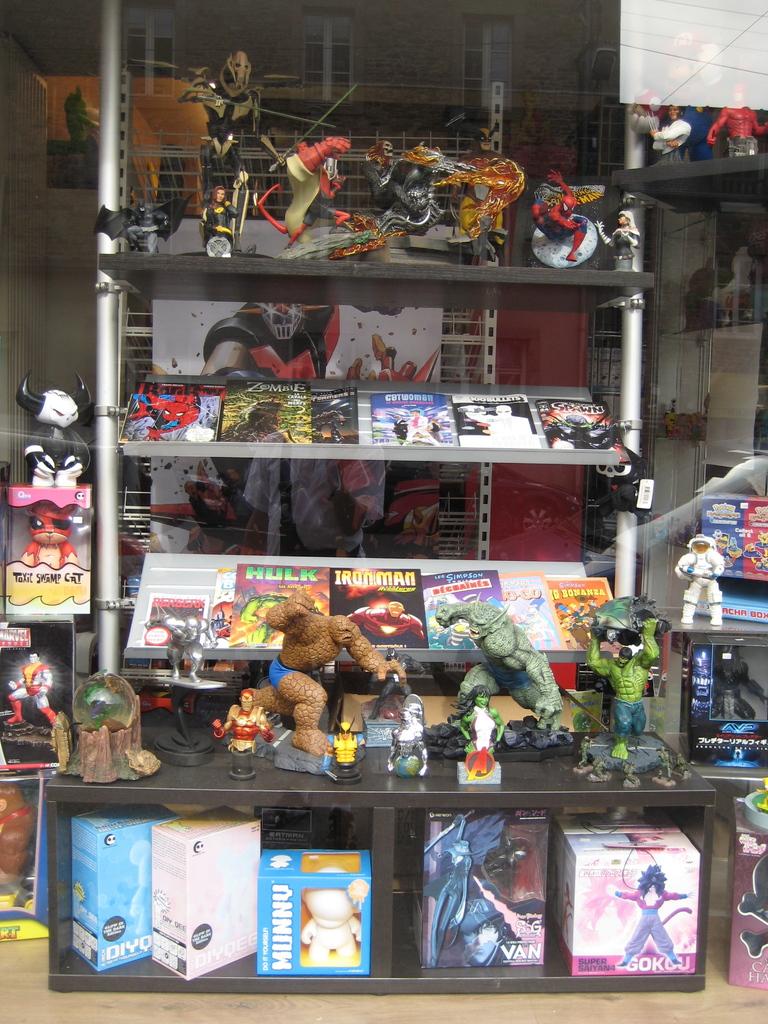What type of comic has the large green letters on the cover?
Keep it short and to the point. Hulk. 